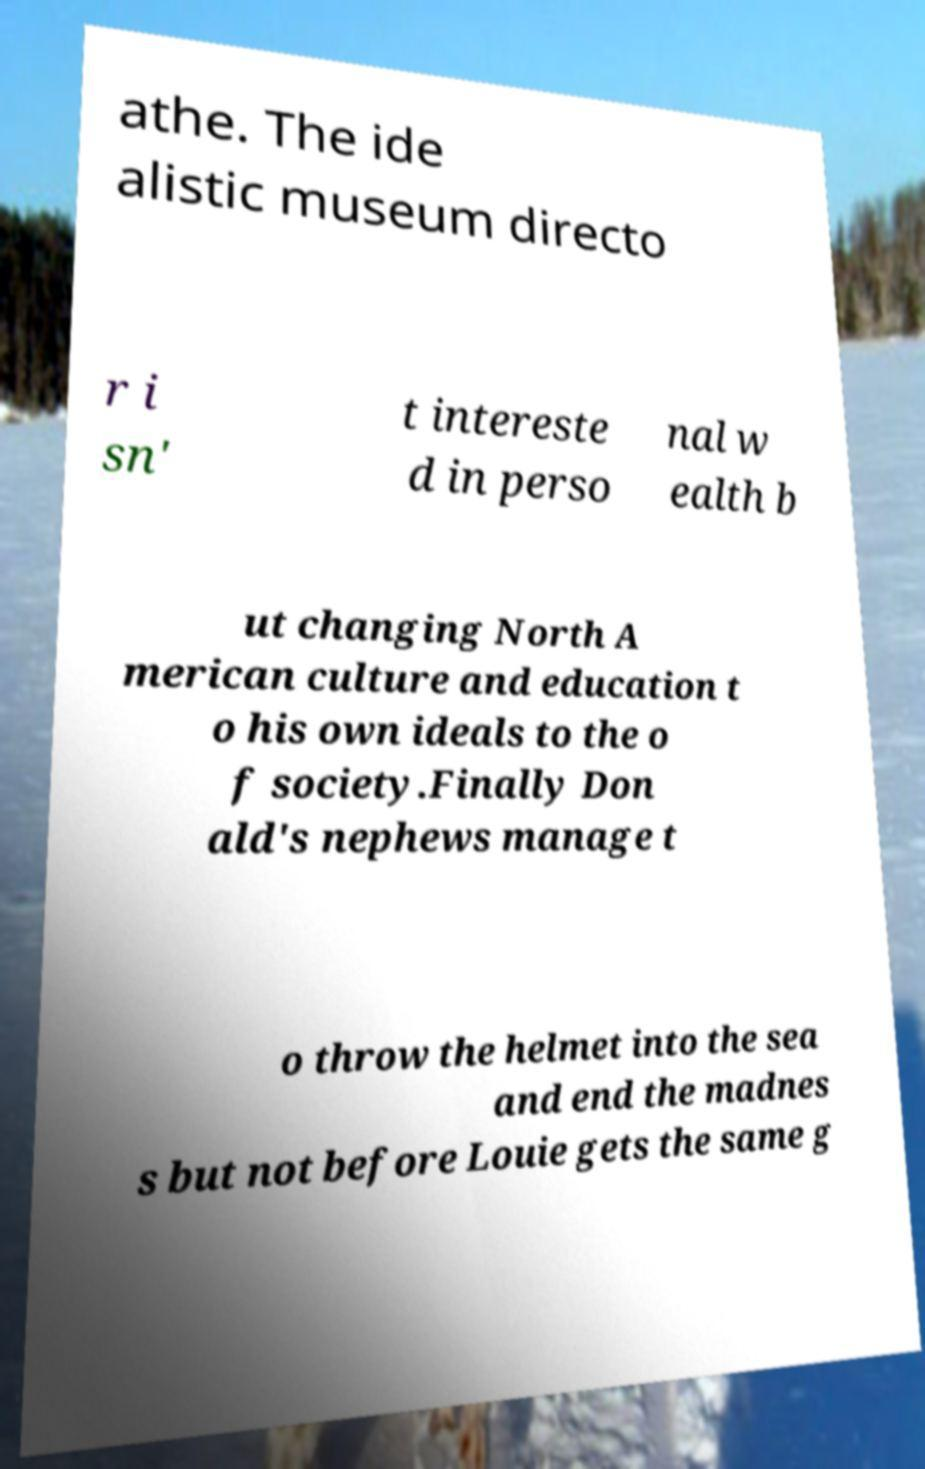Could you extract and type out the text from this image? athe. The ide alistic museum directo r i sn' t intereste d in perso nal w ealth b ut changing North A merican culture and education t o his own ideals to the o f society.Finally Don ald's nephews manage t o throw the helmet into the sea and end the madnes s but not before Louie gets the same g 